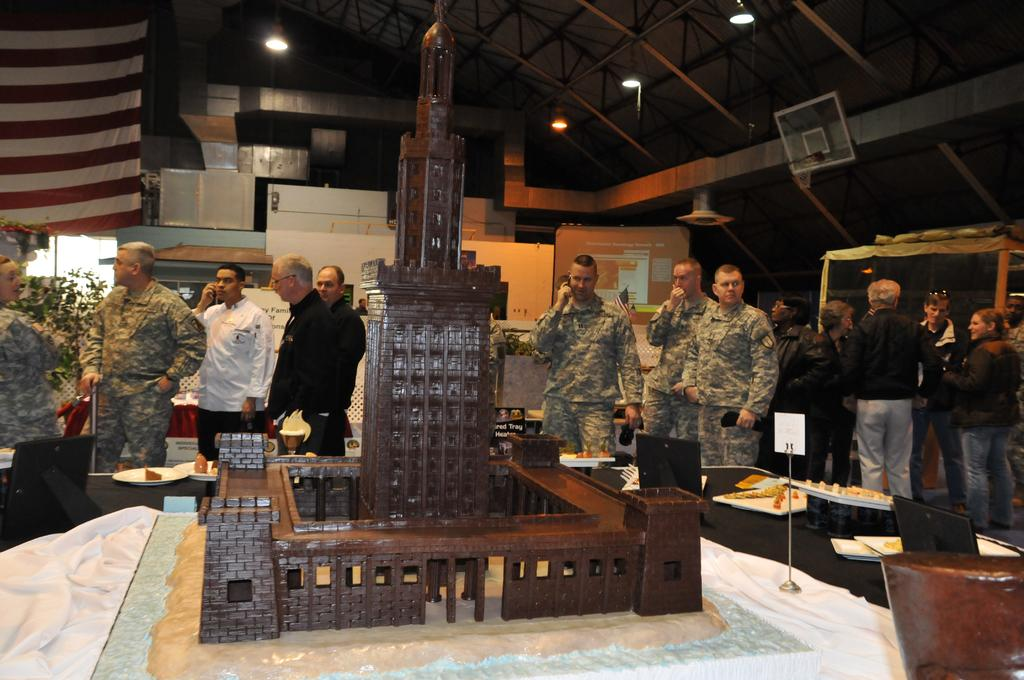What is happening in the image? There are people standing in the image. What can be seen on the table in the image? There is a statue of a building on a table. What else can be seen on a table in the image? There are food items on a plate on another table. How many babies are sitting on the statue of the building in the image? There are no babies present in the image, and the statue of the building is not depicted as having any babies on it. 